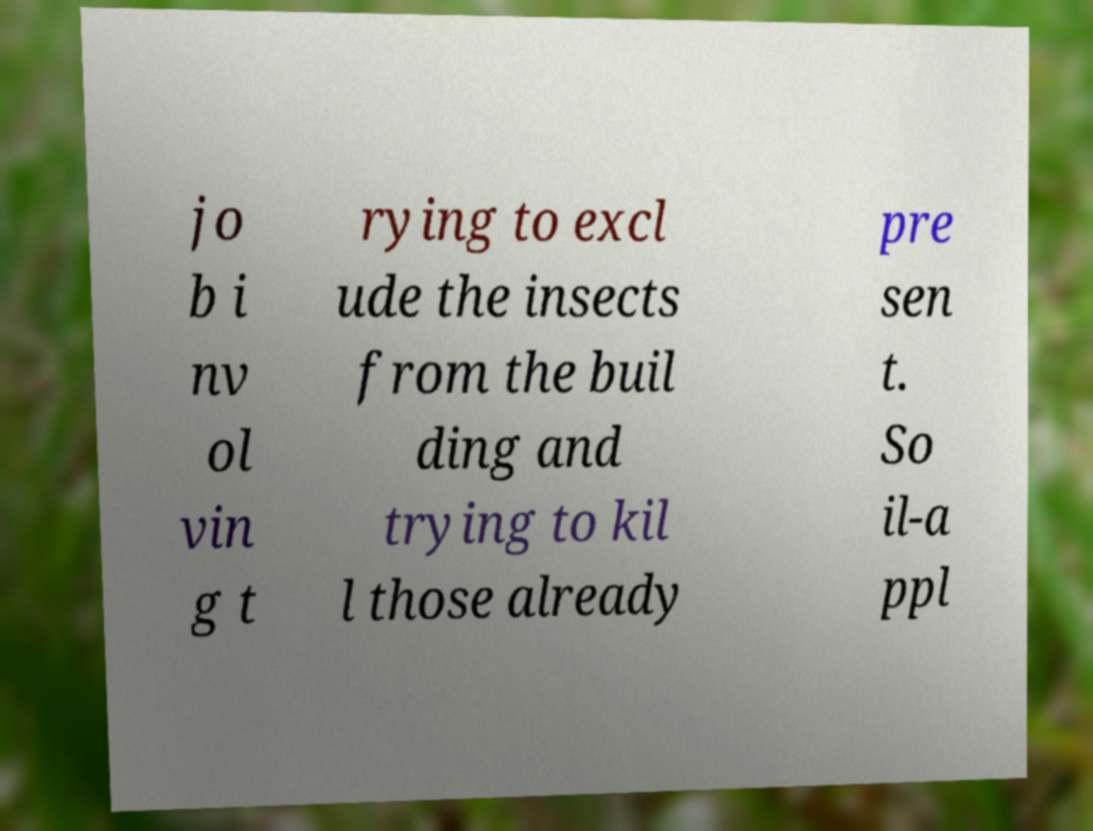I need the written content from this picture converted into text. Can you do that? jo b i nv ol vin g t rying to excl ude the insects from the buil ding and trying to kil l those already pre sen t. So il-a ppl 